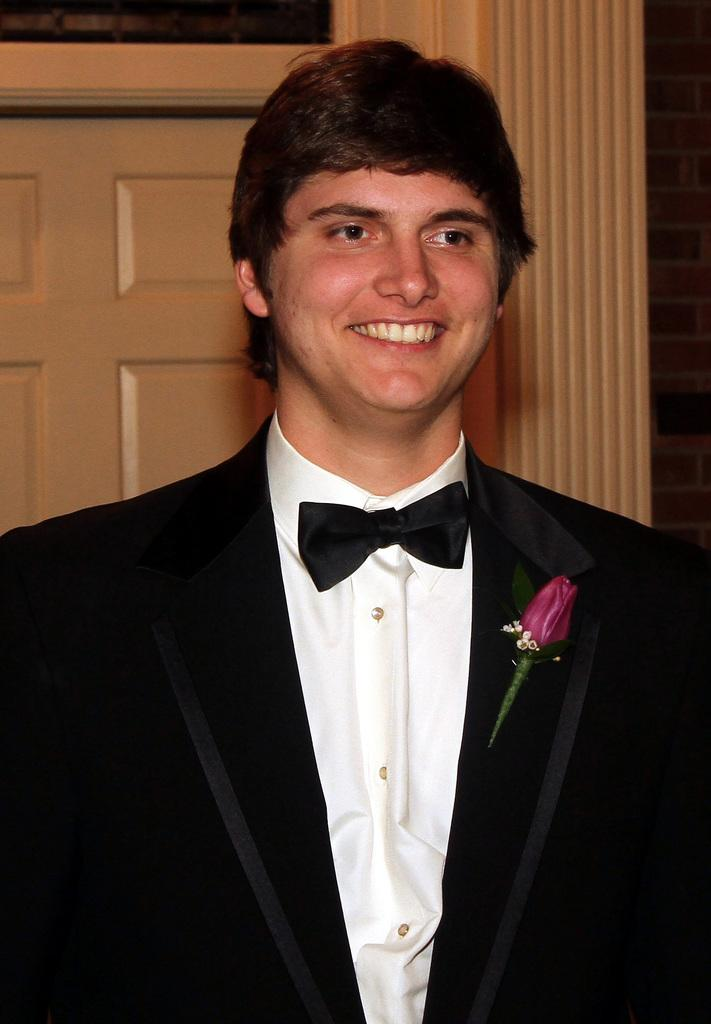Who or what is the main subject in the center of the image? There is a person in the center of the image. What is the person wearing? The person is wearing a suit. What can be seen in the background of the image? There is a door in the background of the image. How many toes can be seen on the person's foot in the image? There is no visible foot or toes in the image, as the person is wearing a suit and the focus is on their upper body. 